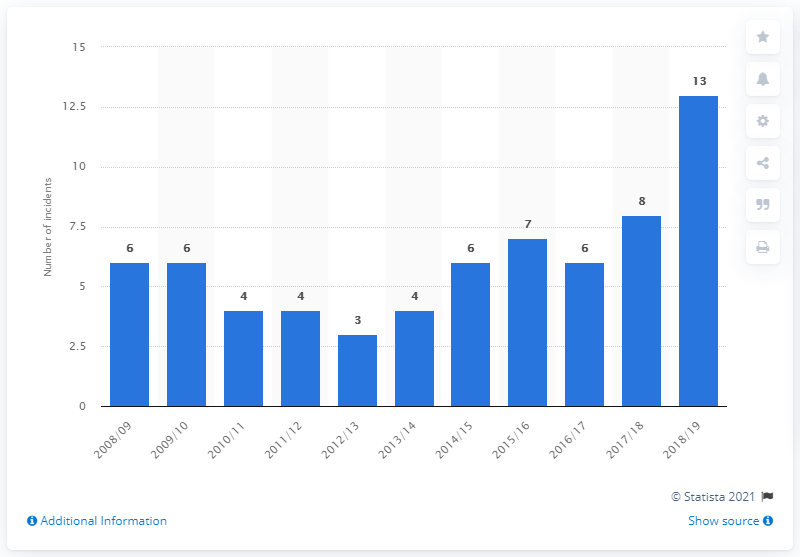Indicate a few pertinent items in this graphic. Between April 1, 2018 and March 31, 2019, the police in England and Wales discharged firearms a total of 13 times. 